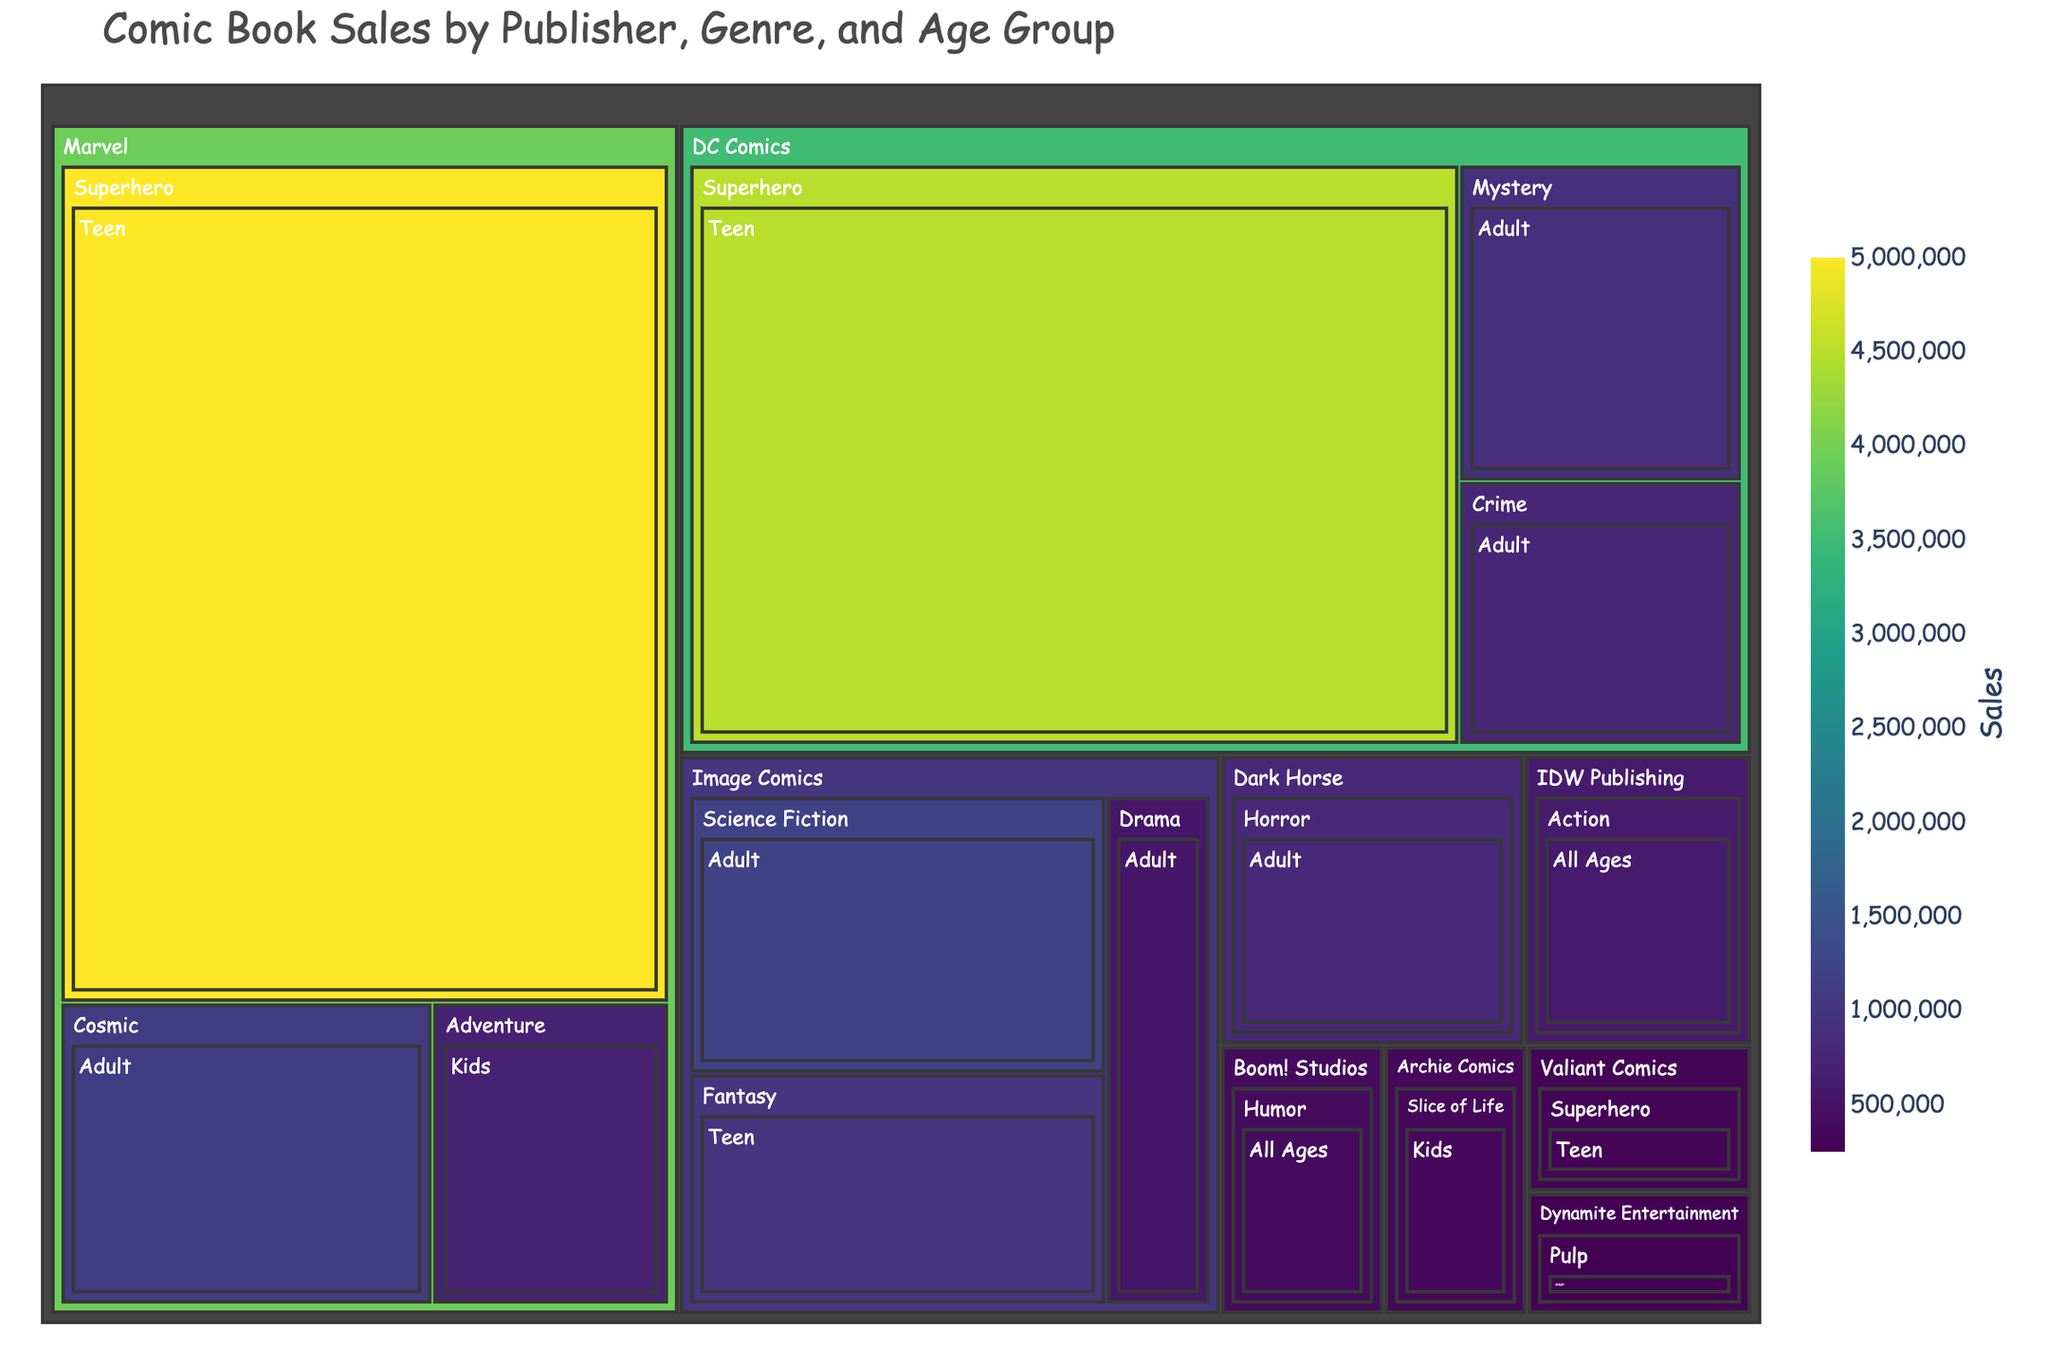What is the title of the treemap? The title is displayed prominently at the top of the treemap in a larger font. It reads: "Comic Book Sales by Publisher, Genre, and Age Group".
Answer: Comic Book Sales by Publisher, Genre, and Age Group Which publisher has the highest total comic book sales according to the treemap? By observing the size of the rectangles, which represent the sales values, Marvel has the largest rectangle, indicating the highest total sales.
Answer: Marvel What genre has the highest sales for DC Comics? Looking at the different genres within the DC Comics section, Superhero has the largest area, indicating the highest sales.
Answer: Superhero How do sales of Marvel's Adventure comics for Kids compare to Marvel's Cosmic comics for Adults? Marvel's Adventure comics for Kids have sales of 700,000, whereas the Cosmic comics for Adults have sales of 1,100,000. Comparing these, Cosmic comics for Adults have higher sales.
Answer: Cosmic comics for Adults have higher sales What is the total sales value of Adult comics by all publishers? Summing up the sales values within the Adult age group: 1,200,000 (Image Comics, Science Fiction) + 800,000 (Dark Horse, Horror) + 900,000 (DC Comics, Mystery) + 1,100,000 (Marvel, Cosmic) + 750,000 (DC Comics, Crime) + 550,000 (Image Comics, Drama) + 250,000 (Dynamite Entertainment, Pulp) = 5,550,000.
Answer: 5,550,000 Which genre from Image Comics targets the Teen age group? The treemap shows one rectangle for Image Comics under the Teen age group, which is Fantasy.
Answer: Fantasy What is the combined sales figure for DC Comics' Superhero and Crime genres? Adding the sales figures from both genres: 4,500,000 (Superhero) + 750,000 (Crime) = 5,250,000.
Answer: 5,250,000 Which publisher has a genre targeted at all ages and what is the sales figure for that genre? By examining the treemap, it’s clear that IDW Publishing has an Action genre targeting all ages with a sales figure of 600,000.
Answer: IDW Publishing, 600,000 Compare the sales figures of the Horror genre between different publishers. Dark Horse is the only publisher in the treemap with the Horror genre, which has sales of 800,000. No comparison is possible with other publishers.
Answer: Only Dark Horse has Horror genre sales, 800,000 How does the total sales for Marvel's Teen comics compare to their Adult comics? Summing up Marvel's Teen comics: 5,000,000 (Superhero). Adult comics: 1,100,000 (Cosmic). Comparing, Teen comics have higher sales.
Answer: Teen comics have higher sales 